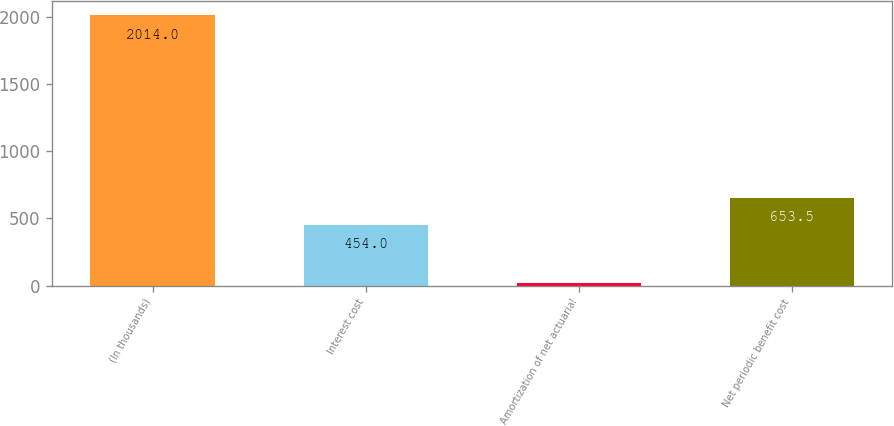Convert chart. <chart><loc_0><loc_0><loc_500><loc_500><bar_chart><fcel>(In thousands)<fcel>Interest cost<fcel>Amortization of net actuarial<fcel>Net periodic benefit cost<nl><fcel>2014<fcel>454<fcel>19<fcel>653.5<nl></chart> 